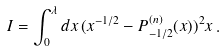<formula> <loc_0><loc_0><loc_500><loc_500>I = \int _ { 0 } ^ { \lambda } d x \, ( x ^ { - 1 / 2 } - P _ { - 1 / 2 } ^ { ( n ) } ( x ) ) ^ { 2 } x \, .</formula> 